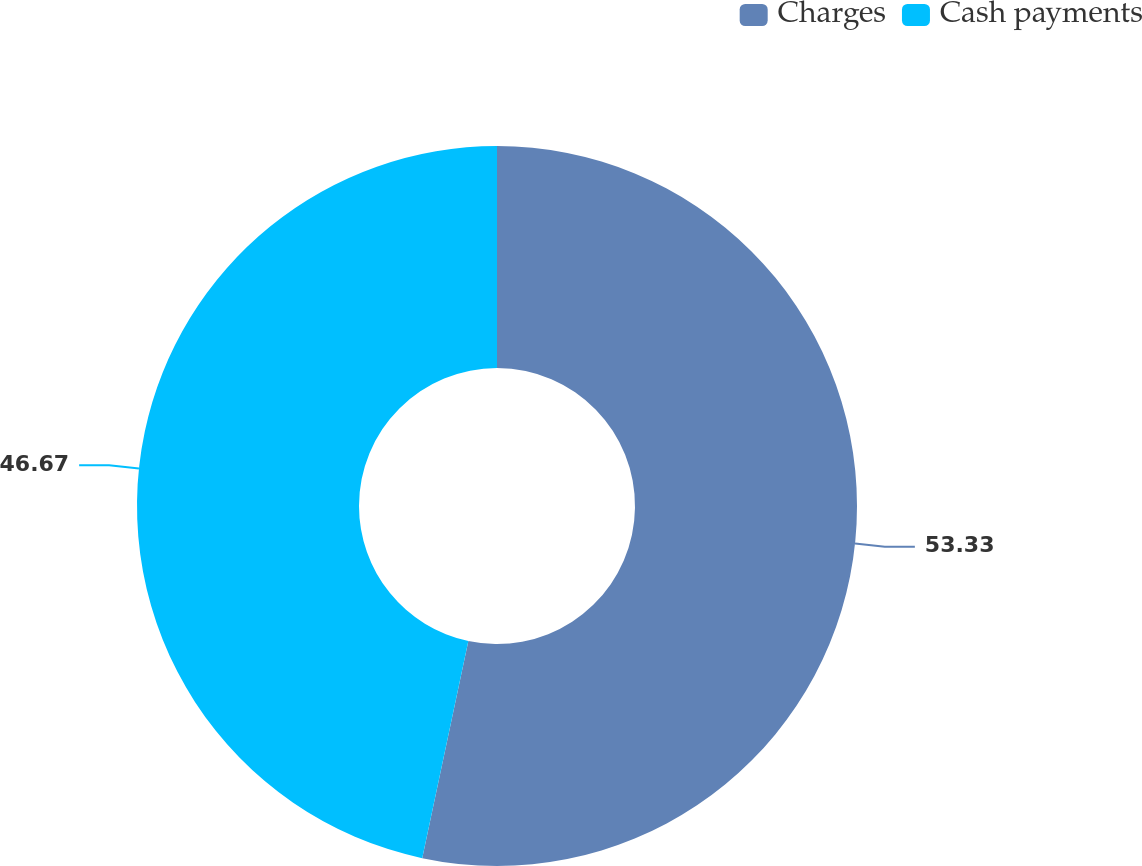<chart> <loc_0><loc_0><loc_500><loc_500><pie_chart><fcel>Charges<fcel>Cash payments<nl><fcel>53.33%<fcel>46.67%<nl></chart> 